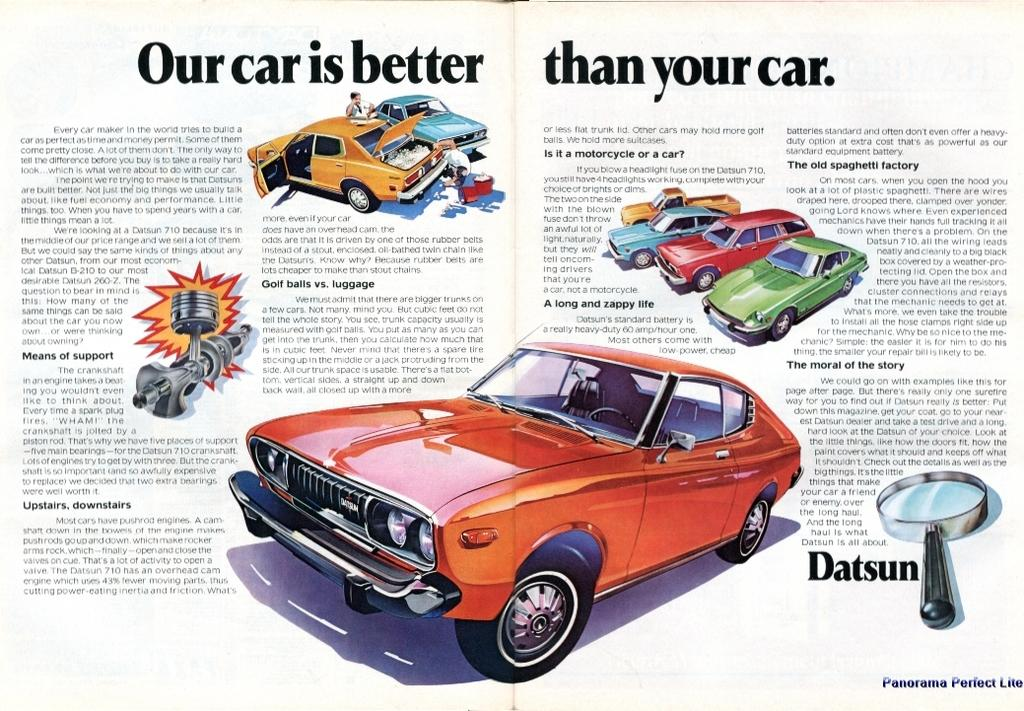What is featured in the image? There is a poster in the image. What can be found on the poster? The poster contains text and images of cars. What type of beam is holding up the poster in the image? There is no beam present in the image; the poster is likely attached to a wall or other surface. 